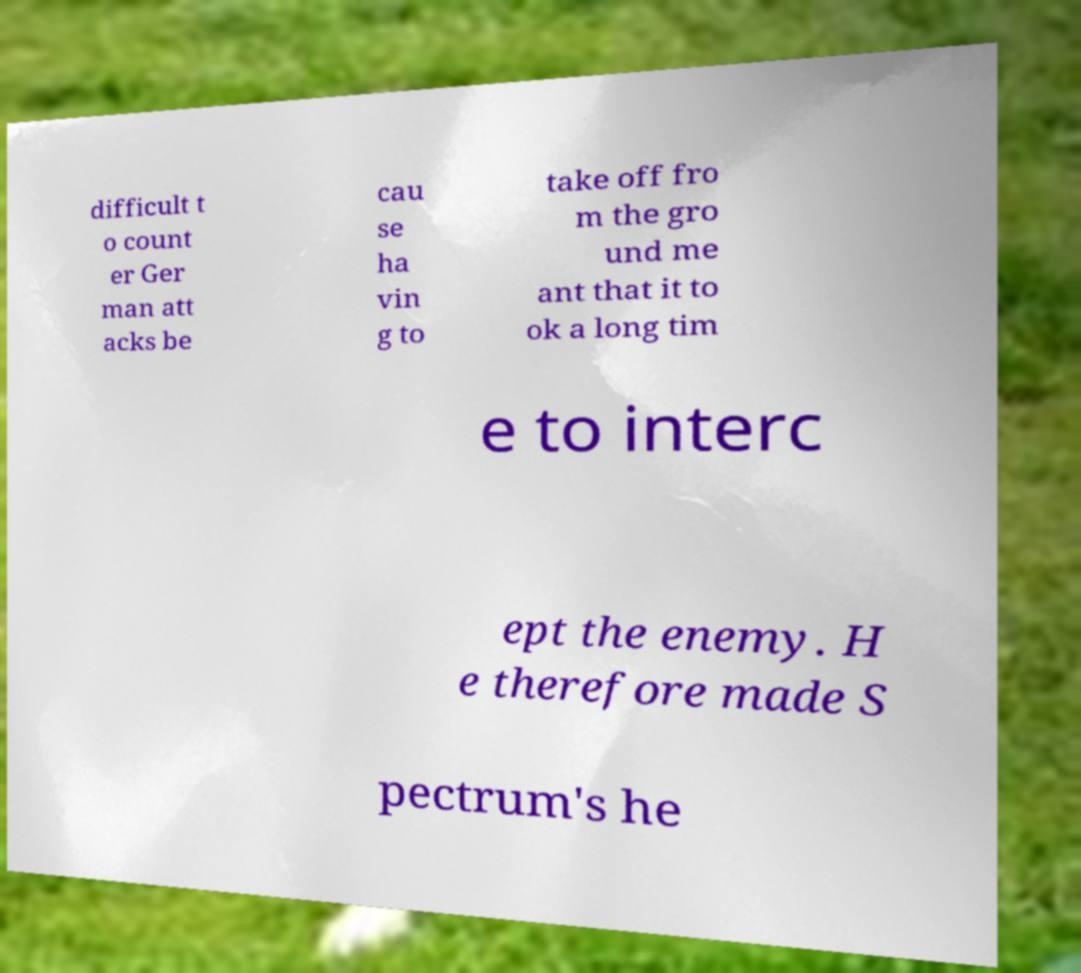For documentation purposes, I need the text within this image transcribed. Could you provide that? difficult t o count er Ger man att acks be cau se ha vin g to take off fro m the gro und me ant that it to ok a long tim e to interc ept the enemy. H e therefore made S pectrum's he 